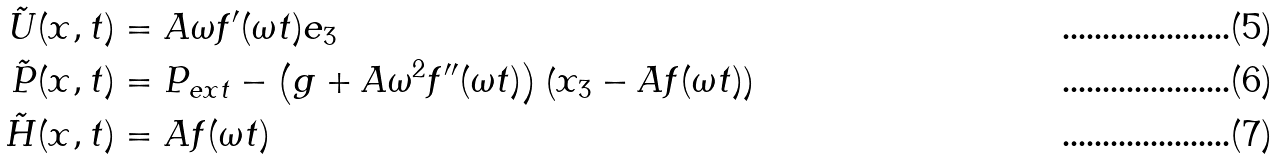<formula> <loc_0><loc_0><loc_500><loc_500>\tilde { U } ( x , t ) & = A \omega f ^ { \prime } ( \omega t ) e _ { 3 } \\ \tilde { P } ( x , t ) & = P _ { e x t } - \left ( g + A \omega ^ { 2 } f ^ { \prime \prime } ( \omega t ) \right ) \left ( x _ { 3 } - A f ( \omega t ) \right ) \\ \tilde { H } ( x , t ) & = A f ( \omega t )</formula> 